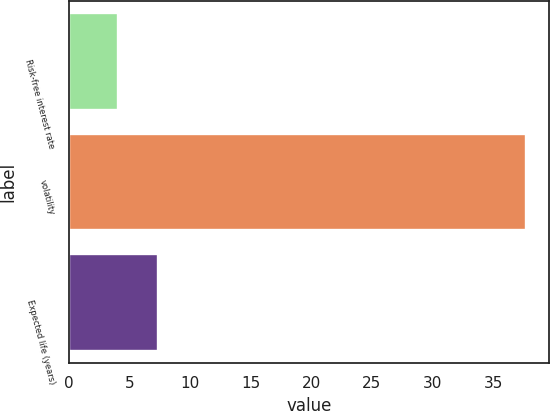<chart> <loc_0><loc_0><loc_500><loc_500><bar_chart><fcel>Risk-free interest rate<fcel>volatility<fcel>Expected life (years)<nl><fcel>4<fcel>37.7<fcel>7.37<nl></chart> 